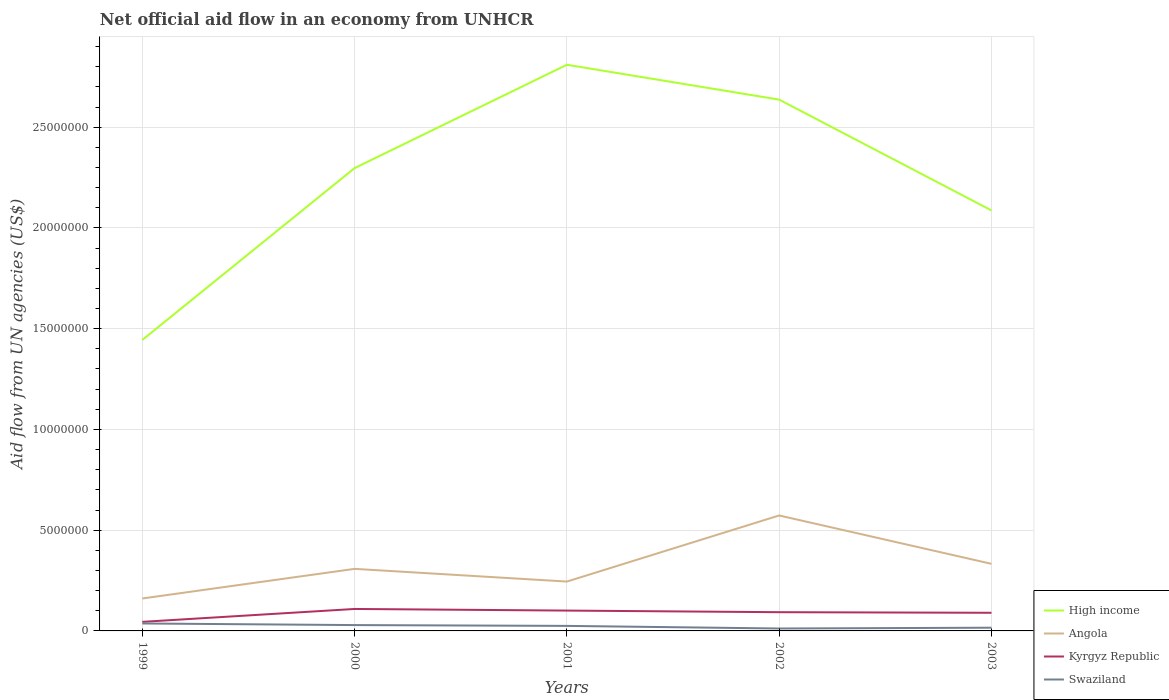How many different coloured lines are there?
Provide a short and direct response. 4. Across all years, what is the maximum net official aid flow in Swaziland?
Provide a succinct answer. 1.20e+05. What is the total net official aid flow in Swaziland in the graph?
Offer a very short reply. -4.00e+04. What is the difference between the highest and the second highest net official aid flow in Angola?
Ensure brevity in your answer.  4.12e+06. What is the difference between two consecutive major ticks on the Y-axis?
Keep it short and to the point. 5.00e+06. Where does the legend appear in the graph?
Your answer should be very brief. Bottom right. How are the legend labels stacked?
Your response must be concise. Vertical. What is the title of the graph?
Offer a terse response. Net official aid flow in an economy from UNHCR. What is the label or title of the Y-axis?
Offer a very short reply. Aid flow from UN agencies (US$). What is the Aid flow from UN agencies (US$) of High income in 1999?
Your answer should be compact. 1.44e+07. What is the Aid flow from UN agencies (US$) of Angola in 1999?
Ensure brevity in your answer.  1.61e+06. What is the Aid flow from UN agencies (US$) in Kyrgyz Republic in 1999?
Offer a very short reply. 4.50e+05. What is the Aid flow from UN agencies (US$) of Swaziland in 1999?
Keep it short and to the point. 3.70e+05. What is the Aid flow from UN agencies (US$) of High income in 2000?
Offer a terse response. 2.30e+07. What is the Aid flow from UN agencies (US$) of Angola in 2000?
Give a very brief answer. 3.08e+06. What is the Aid flow from UN agencies (US$) of Kyrgyz Republic in 2000?
Make the answer very short. 1.09e+06. What is the Aid flow from UN agencies (US$) in High income in 2001?
Offer a terse response. 2.81e+07. What is the Aid flow from UN agencies (US$) in Angola in 2001?
Keep it short and to the point. 2.45e+06. What is the Aid flow from UN agencies (US$) in Kyrgyz Republic in 2001?
Provide a short and direct response. 1.01e+06. What is the Aid flow from UN agencies (US$) in Swaziland in 2001?
Offer a terse response. 2.50e+05. What is the Aid flow from UN agencies (US$) of High income in 2002?
Offer a terse response. 2.64e+07. What is the Aid flow from UN agencies (US$) in Angola in 2002?
Provide a succinct answer. 5.73e+06. What is the Aid flow from UN agencies (US$) of Kyrgyz Republic in 2002?
Ensure brevity in your answer.  9.30e+05. What is the Aid flow from UN agencies (US$) of Swaziland in 2002?
Your answer should be very brief. 1.20e+05. What is the Aid flow from UN agencies (US$) of High income in 2003?
Give a very brief answer. 2.09e+07. What is the Aid flow from UN agencies (US$) of Angola in 2003?
Provide a short and direct response. 3.33e+06. What is the Aid flow from UN agencies (US$) of Swaziland in 2003?
Make the answer very short. 1.60e+05. Across all years, what is the maximum Aid flow from UN agencies (US$) in High income?
Keep it short and to the point. 2.81e+07. Across all years, what is the maximum Aid flow from UN agencies (US$) in Angola?
Your response must be concise. 5.73e+06. Across all years, what is the maximum Aid flow from UN agencies (US$) of Kyrgyz Republic?
Offer a very short reply. 1.09e+06. Across all years, what is the maximum Aid flow from UN agencies (US$) in Swaziland?
Offer a terse response. 3.70e+05. Across all years, what is the minimum Aid flow from UN agencies (US$) of High income?
Keep it short and to the point. 1.44e+07. Across all years, what is the minimum Aid flow from UN agencies (US$) of Angola?
Provide a succinct answer. 1.61e+06. Across all years, what is the minimum Aid flow from UN agencies (US$) of Kyrgyz Republic?
Keep it short and to the point. 4.50e+05. What is the total Aid flow from UN agencies (US$) of High income in the graph?
Provide a short and direct response. 1.13e+08. What is the total Aid flow from UN agencies (US$) in Angola in the graph?
Keep it short and to the point. 1.62e+07. What is the total Aid flow from UN agencies (US$) in Kyrgyz Republic in the graph?
Offer a terse response. 4.38e+06. What is the total Aid flow from UN agencies (US$) in Swaziland in the graph?
Your answer should be very brief. 1.19e+06. What is the difference between the Aid flow from UN agencies (US$) of High income in 1999 and that in 2000?
Your response must be concise. -8.53e+06. What is the difference between the Aid flow from UN agencies (US$) of Angola in 1999 and that in 2000?
Offer a terse response. -1.47e+06. What is the difference between the Aid flow from UN agencies (US$) in Kyrgyz Republic in 1999 and that in 2000?
Your answer should be very brief. -6.40e+05. What is the difference between the Aid flow from UN agencies (US$) of Swaziland in 1999 and that in 2000?
Provide a succinct answer. 8.00e+04. What is the difference between the Aid flow from UN agencies (US$) of High income in 1999 and that in 2001?
Your answer should be compact. -1.37e+07. What is the difference between the Aid flow from UN agencies (US$) of Angola in 1999 and that in 2001?
Keep it short and to the point. -8.40e+05. What is the difference between the Aid flow from UN agencies (US$) of Kyrgyz Republic in 1999 and that in 2001?
Keep it short and to the point. -5.60e+05. What is the difference between the Aid flow from UN agencies (US$) of Swaziland in 1999 and that in 2001?
Provide a succinct answer. 1.20e+05. What is the difference between the Aid flow from UN agencies (US$) in High income in 1999 and that in 2002?
Offer a very short reply. -1.19e+07. What is the difference between the Aid flow from UN agencies (US$) of Angola in 1999 and that in 2002?
Your response must be concise. -4.12e+06. What is the difference between the Aid flow from UN agencies (US$) of Kyrgyz Republic in 1999 and that in 2002?
Your answer should be very brief. -4.80e+05. What is the difference between the Aid flow from UN agencies (US$) in Swaziland in 1999 and that in 2002?
Your answer should be very brief. 2.50e+05. What is the difference between the Aid flow from UN agencies (US$) in High income in 1999 and that in 2003?
Provide a short and direct response. -6.43e+06. What is the difference between the Aid flow from UN agencies (US$) in Angola in 1999 and that in 2003?
Provide a short and direct response. -1.72e+06. What is the difference between the Aid flow from UN agencies (US$) in Kyrgyz Republic in 1999 and that in 2003?
Offer a very short reply. -4.50e+05. What is the difference between the Aid flow from UN agencies (US$) in High income in 2000 and that in 2001?
Ensure brevity in your answer.  -5.13e+06. What is the difference between the Aid flow from UN agencies (US$) in Angola in 2000 and that in 2001?
Provide a short and direct response. 6.30e+05. What is the difference between the Aid flow from UN agencies (US$) in Kyrgyz Republic in 2000 and that in 2001?
Offer a terse response. 8.00e+04. What is the difference between the Aid flow from UN agencies (US$) in Swaziland in 2000 and that in 2001?
Your answer should be very brief. 4.00e+04. What is the difference between the Aid flow from UN agencies (US$) in High income in 2000 and that in 2002?
Your answer should be very brief. -3.40e+06. What is the difference between the Aid flow from UN agencies (US$) in Angola in 2000 and that in 2002?
Your answer should be compact. -2.65e+06. What is the difference between the Aid flow from UN agencies (US$) of Kyrgyz Republic in 2000 and that in 2002?
Ensure brevity in your answer.  1.60e+05. What is the difference between the Aid flow from UN agencies (US$) of Swaziland in 2000 and that in 2002?
Your answer should be very brief. 1.70e+05. What is the difference between the Aid flow from UN agencies (US$) of High income in 2000 and that in 2003?
Keep it short and to the point. 2.10e+06. What is the difference between the Aid flow from UN agencies (US$) of Angola in 2000 and that in 2003?
Provide a succinct answer. -2.50e+05. What is the difference between the Aid flow from UN agencies (US$) of High income in 2001 and that in 2002?
Your response must be concise. 1.73e+06. What is the difference between the Aid flow from UN agencies (US$) of Angola in 2001 and that in 2002?
Offer a very short reply. -3.28e+06. What is the difference between the Aid flow from UN agencies (US$) of Kyrgyz Republic in 2001 and that in 2002?
Your answer should be compact. 8.00e+04. What is the difference between the Aid flow from UN agencies (US$) of Swaziland in 2001 and that in 2002?
Your answer should be compact. 1.30e+05. What is the difference between the Aid flow from UN agencies (US$) in High income in 2001 and that in 2003?
Your response must be concise. 7.23e+06. What is the difference between the Aid flow from UN agencies (US$) of Angola in 2001 and that in 2003?
Your answer should be very brief. -8.80e+05. What is the difference between the Aid flow from UN agencies (US$) in Kyrgyz Republic in 2001 and that in 2003?
Provide a succinct answer. 1.10e+05. What is the difference between the Aid flow from UN agencies (US$) of High income in 2002 and that in 2003?
Offer a terse response. 5.50e+06. What is the difference between the Aid flow from UN agencies (US$) of Angola in 2002 and that in 2003?
Offer a terse response. 2.40e+06. What is the difference between the Aid flow from UN agencies (US$) of High income in 1999 and the Aid flow from UN agencies (US$) of Angola in 2000?
Your answer should be compact. 1.14e+07. What is the difference between the Aid flow from UN agencies (US$) of High income in 1999 and the Aid flow from UN agencies (US$) of Kyrgyz Republic in 2000?
Offer a very short reply. 1.34e+07. What is the difference between the Aid flow from UN agencies (US$) of High income in 1999 and the Aid flow from UN agencies (US$) of Swaziland in 2000?
Keep it short and to the point. 1.42e+07. What is the difference between the Aid flow from UN agencies (US$) of Angola in 1999 and the Aid flow from UN agencies (US$) of Kyrgyz Republic in 2000?
Make the answer very short. 5.20e+05. What is the difference between the Aid flow from UN agencies (US$) in Angola in 1999 and the Aid flow from UN agencies (US$) in Swaziland in 2000?
Offer a very short reply. 1.32e+06. What is the difference between the Aid flow from UN agencies (US$) of High income in 1999 and the Aid flow from UN agencies (US$) of Angola in 2001?
Provide a succinct answer. 1.20e+07. What is the difference between the Aid flow from UN agencies (US$) of High income in 1999 and the Aid flow from UN agencies (US$) of Kyrgyz Republic in 2001?
Give a very brief answer. 1.34e+07. What is the difference between the Aid flow from UN agencies (US$) of High income in 1999 and the Aid flow from UN agencies (US$) of Swaziland in 2001?
Give a very brief answer. 1.42e+07. What is the difference between the Aid flow from UN agencies (US$) of Angola in 1999 and the Aid flow from UN agencies (US$) of Kyrgyz Republic in 2001?
Ensure brevity in your answer.  6.00e+05. What is the difference between the Aid flow from UN agencies (US$) in Angola in 1999 and the Aid flow from UN agencies (US$) in Swaziland in 2001?
Give a very brief answer. 1.36e+06. What is the difference between the Aid flow from UN agencies (US$) in High income in 1999 and the Aid flow from UN agencies (US$) in Angola in 2002?
Ensure brevity in your answer.  8.71e+06. What is the difference between the Aid flow from UN agencies (US$) in High income in 1999 and the Aid flow from UN agencies (US$) in Kyrgyz Republic in 2002?
Give a very brief answer. 1.35e+07. What is the difference between the Aid flow from UN agencies (US$) of High income in 1999 and the Aid flow from UN agencies (US$) of Swaziland in 2002?
Make the answer very short. 1.43e+07. What is the difference between the Aid flow from UN agencies (US$) in Angola in 1999 and the Aid flow from UN agencies (US$) in Kyrgyz Republic in 2002?
Give a very brief answer. 6.80e+05. What is the difference between the Aid flow from UN agencies (US$) in Angola in 1999 and the Aid flow from UN agencies (US$) in Swaziland in 2002?
Provide a short and direct response. 1.49e+06. What is the difference between the Aid flow from UN agencies (US$) in High income in 1999 and the Aid flow from UN agencies (US$) in Angola in 2003?
Provide a short and direct response. 1.11e+07. What is the difference between the Aid flow from UN agencies (US$) of High income in 1999 and the Aid flow from UN agencies (US$) of Kyrgyz Republic in 2003?
Your answer should be very brief. 1.35e+07. What is the difference between the Aid flow from UN agencies (US$) of High income in 1999 and the Aid flow from UN agencies (US$) of Swaziland in 2003?
Offer a very short reply. 1.43e+07. What is the difference between the Aid flow from UN agencies (US$) of Angola in 1999 and the Aid flow from UN agencies (US$) of Kyrgyz Republic in 2003?
Your answer should be very brief. 7.10e+05. What is the difference between the Aid flow from UN agencies (US$) of Angola in 1999 and the Aid flow from UN agencies (US$) of Swaziland in 2003?
Your answer should be very brief. 1.45e+06. What is the difference between the Aid flow from UN agencies (US$) of Kyrgyz Republic in 1999 and the Aid flow from UN agencies (US$) of Swaziland in 2003?
Provide a succinct answer. 2.90e+05. What is the difference between the Aid flow from UN agencies (US$) in High income in 2000 and the Aid flow from UN agencies (US$) in Angola in 2001?
Make the answer very short. 2.05e+07. What is the difference between the Aid flow from UN agencies (US$) in High income in 2000 and the Aid flow from UN agencies (US$) in Kyrgyz Republic in 2001?
Your response must be concise. 2.20e+07. What is the difference between the Aid flow from UN agencies (US$) in High income in 2000 and the Aid flow from UN agencies (US$) in Swaziland in 2001?
Ensure brevity in your answer.  2.27e+07. What is the difference between the Aid flow from UN agencies (US$) in Angola in 2000 and the Aid flow from UN agencies (US$) in Kyrgyz Republic in 2001?
Provide a succinct answer. 2.07e+06. What is the difference between the Aid flow from UN agencies (US$) in Angola in 2000 and the Aid flow from UN agencies (US$) in Swaziland in 2001?
Your response must be concise. 2.83e+06. What is the difference between the Aid flow from UN agencies (US$) in Kyrgyz Republic in 2000 and the Aid flow from UN agencies (US$) in Swaziland in 2001?
Your answer should be compact. 8.40e+05. What is the difference between the Aid flow from UN agencies (US$) in High income in 2000 and the Aid flow from UN agencies (US$) in Angola in 2002?
Provide a succinct answer. 1.72e+07. What is the difference between the Aid flow from UN agencies (US$) of High income in 2000 and the Aid flow from UN agencies (US$) of Kyrgyz Republic in 2002?
Ensure brevity in your answer.  2.20e+07. What is the difference between the Aid flow from UN agencies (US$) in High income in 2000 and the Aid flow from UN agencies (US$) in Swaziland in 2002?
Provide a short and direct response. 2.28e+07. What is the difference between the Aid flow from UN agencies (US$) of Angola in 2000 and the Aid flow from UN agencies (US$) of Kyrgyz Republic in 2002?
Ensure brevity in your answer.  2.15e+06. What is the difference between the Aid flow from UN agencies (US$) in Angola in 2000 and the Aid flow from UN agencies (US$) in Swaziland in 2002?
Offer a very short reply. 2.96e+06. What is the difference between the Aid flow from UN agencies (US$) of Kyrgyz Republic in 2000 and the Aid flow from UN agencies (US$) of Swaziland in 2002?
Make the answer very short. 9.70e+05. What is the difference between the Aid flow from UN agencies (US$) of High income in 2000 and the Aid flow from UN agencies (US$) of Angola in 2003?
Your answer should be compact. 1.96e+07. What is the difference between the Aid flow from UN agencies (US$) in High income in 2000 and the Aid flow from UN agencies (US$) in Kyrgyz Republic in 2003?
Provide a succinct answer. 2.21e+07. What is the difference between the Aid flow from UN agencies (US$) of High income in 2000 and the Aid flow from UN agencies (US$) of Swaziland in 2003?
Offer a terse response. 2.28e+07. What is the difference between the Aid flow from UN agencies (US$) of Angola in 2000 and the Aid flow from UN agencies (US$) of Kyrgyz Republic in 2003?
Make the answer very short. 2.18e+06. What is the difference between the Aid flow from UN agencies (US$) in Angola in 2000 and the Aid flow from UN agencies (US$) in Swaziland in 2003?
Provide a short and direct response. 2.92e+06. What is the difference between the Aid flow from UN agencies (US$) of Kyrgyz Republic in 2000 and the Aid flow from UN agencies (US$) of Swaziland in 2003?
Provide a short and direct response. 9.30e+05. What is the difference between the Aid flow from UN agencies (US$) in High income in 2001 and the Aid flow from UN agencies (US$) in Angola in 2002?
Your answer should be compact. 2.24e+07. What is the difference between the Aid flow from UN agencies (US$) of High income in 2001 and the Aid flow from UN agencies (US$) of Kyrgyz Republic in 2002?
Make the answer very short. 2.72e+07. What is the difference between the Aid flow from UN agencies (US$) in High income in 2001 and the Aid flow from UN agencies (US$) in Swaziland in 2002?
Give a very brief answer. 2.80e+07. What is the difference between the Aid flow from UN agencies (US$) in Angola in 2001 and the Aid flow from UN agencies (US$) in Kyrgyz Republic in 2002?
Provide a succinct answer. 1.52e+06. What is the difference between the Aid flow from UN agencies (US$) of Angola in 2001 and the Aid flow from UN agencies (US$) of Swaziland in 2002?
Your response must be concise. 2.33e+06. What is the difference between the Aid flow from UN agencies (US$) of Kyrgyz Republic in 2001 and the Aid flow from UN agencies (US$) of Swaziland in 2002?
Ensure brevity in your answer.  8.90e+05. What is the difference between the Aid flow from UN agencies (US$) of High income in 2001 and the Aid flow from UN agencies (US$) of Angola in 2003?
Your answer should be very brief. 2.48e+07. What is the difference between the Aid flow from UN agencies (US$) of High income in 2001 and the Aid flow from UN agencies (US$) of Kyrgyz Republic in 2003?
Keep it short and to the point. 2.72e+07. What is the difference between the Aid flow from UN agencies (US$) in High income in 2001 and the Aid flow from UN agencies (US$) in Swaziland in 2003?
Offer a terse response. 2.79e+07. What is the difference between the Aid flow from UN agencies (US$) in Angola in 2001 and the Aid flow from UN agencies (US$) in Kyrgyz Republic in 2003?
Ensure brevity in your answer.  1.55e+06. What is the difference between the Aid flow from UN agencies (US$) in Angola in 2001 and the Aid flow from UN agencies (US$) in Swaziland in 2003?
Provide a succinct answer. 2.29e+06. What is the difference between the Aid flow from UN agencies (US$) of Kyrgyz Republic in 2001 and the Aid flow from UN agencies (US$) of Swaziland in 2003?
Give a very brief answer. 8.50e+05. What is the difference between the Aid flow from UN agencies (US$) in High income in 2002 and the Aid flow from UN agencies (US$) in Angola in 2003?
Your answer should be compact. 2.30e+07. What is the difference between the Aid flow from UN agencies (US$) in High income in 2002 and the Aid flow from UN agencies (US$) in Kyrgyz Republic in 2003?
Your answer should be very brief. 2.55e+07. What is the difference between the Aid flow from UN agencies (US$) of High income in 2002 and the Aid flow from UN agencies (US$) of Swaziland in 2003?
Your answer should be compact. 2.62e+07. What is the difference between the Aid flow from UN agencies (US$) in Angola in 2002 and the Aid flow from UN agencies (US$) in Kyrgyz Republic in 2003?
Offer a terse response. 4.83e+06. What is the difference between the Aid flow from UN agencies (US$) of Angola in 2002 and the Aid flow from UN agencies (US$) of Swaziland in 2003?
Give a very brief answer. 5.57e+06. What is the difference between the Aid flow from UN agencies (US$) of Kyrgyz Republic in 2002 and the Aid flow from UN agencies (US$) of Swaziland in 2003?
Your response must be concise. 7.70e+05. What is the average Aid flow from UN agencies (US$) in High income per year?
Your response must be concise. 2.26e+07. What is the average Aid flow from UN agencies (US$) of Angola per year?
Your response must be concise. 3.24e+06. What is the average Aid flow from UN agencies (US$) of Kyrgyz Republic per year?
Offer a very short reply. 8.76e+05. What is the average Aid flow from UN agencies (US$) of Swaziland per year?
Ensure brevity in your answer.  2.38e+05. In the year 1999, what is the difference between the Aid flow from UN agencies (US$) of High income and Aid flow from UN agencies (US$) of Angola?
Give a very brief answer. 1.28e+07. In the year 1999, what is the difference between the Aid flow from UN agencies (US$) of High income and Aid flow from UN agencies (US$) of Kyrgyz Republic?
Your answer should be compact. 1.40e+07. In the year 1999, what is the difference between the Aid flow from UN agencies (US$) in High income and Aid flow from UN agencies (US$) in Swaziland?
Your response must be concise. 1.41e+07. In the year 1999, what is the difference between the Aid flow from UN agencies (US$) of Angola and Aid flow from UN agencies (US$) of Kyrgyz Republic?
Ensure brevity in your answer.  1.16e+06. In the year 1999, what is the difference between the Aid flow from UN agencies (US$) of Angola and Aid flow from UN agencies (US$) of Swaziland?
Give a very brief answer. 1.24e+06. In the year 1999, what is the difference between the Aid flow from UN agencies (US$) in Kyrgyz Republic and Aid flow from UN agencies (US$) in Swaziland?
Offer a very short reply. 8.00e+04. In the year 2000, what is the difference between the Aid flow from UN agencies (US$) of High income and Aid flow from UN agencies (US$) of Angola?
Ensure brevity in your answer.  1.99e+07. In the year 2000, what is the difference between the Aid flow from UN agencies (US$) of High income and Aid flow from UN agencies (US$) of Kyrgyz Republic?
Your answer should be very brief. 2.19e+07. In the year 2000, what is the difference between the Aid flow from UN agencies (US$) in High income and Aid flow from UN agencies (US$) in Swaziland?
Provide a short and direct response. 2.27e+07. In the year 2000, what is the difference between the Aid flow from UN agencies (US$) of Angola and Aid flow from UN agencies (US$) of Kyrgyz Republic?
Give a very brief answer. 1.99e+06. In the year 2000, what is the difference between the Aid flow from UN agencies (US$) in Angola and Aid flow from UN agencies (US$) in Swaziland?
Your response must be concise. 2.79e+06. In the year 2000, what is the difference between the Aid flow from UN agencies (US$) in Kyrgyz Republic and Aid flow from UN agencies (US$) in Swaziland?
Offer a very short reply. 8.00e+05. In the year 2001, what is the difference between the Aid flow from UN agencies (US$) of High income and Aid flow from UN agencies (US$) of Angola?
Make the answer very short. 2.56e+07. In the year 2001, what is the difference between the Aid flow from UN agencies (US$) in High income and Aid flow from UN agencies (US$) in Kyrgyz Republic?
Keep it short and to the point. 2.71e+07. In the year 2001, what is the difference between the Aid flow from UN agencies (US$) of High income and Aid flow from UN agencies (US$) of Swaziland?
Keep it short and to the point. 2.78e+07. In the year 2001, what is the difference between the Aid flow from UN agencies (US$) in Angola and Aid flow from UN agencies (US$) in Kyrgyz Republic?
Make the answer very short. 1.44e+06. In the year 2001, what is the difference between the Aid flow from UN agencies (US$) of Angola and Aid flow from UN agencies (US$) of Swaziland?
Your answer should be compact. 2.20e+06. In the year 2001, what is the difference between the Aid flow from UN agencies (US$) in Kyrgyz Republic and Aid flow from UN agencies (US$) in Swaziland?
Your response must be concise. 7.60e+05. In the year 2002, what is the difference between the Aid flow from UN agencies (US$) in High income and Aid flow from UN agencies (US$) in Angola?
Offer a terse response. 2.06e+07. In the year 2002, what is the difference between the Aid flow from UN agencies (US$) in High income and Aid flow from UN agencies (US$) in Kyrgyz Republic?
Offer a very short reply. 2.54e+07. In the year 2002, what is the difference between the Aid flow from UN agencies (US$) in High income and Aid flow from UN agencies (US$) in Swaziland?
Make the answer very short. 2.62e+07. In the year 2002, what is the difference between the Aid flow from UN agencies (US$) in Angola and Aid flow from UN agencies (US$) in Kyrgyz Republic?
Provide a succinct answer. 4.80e+06. In the year 2002, what is the difference between the Aid flow from UN agencies (US$) in Angola and Aid flow from UN agencies (US$) in Swaziland?
Your answer should be compact. 5.61e+06. In the year 2002, what is the difference between the Aid flow from UN agencies (US$) in Kyrgyz Republic and Aid flow from UN agencies (US$) in Swaziland?
Your response must be concise. 8.10e+05. In the year 2003, what is the difference between the Aid flow from UN agencies (US$) of High income and Aid flow from UN agencies (US$) of Angola?
Provide a short and direct response. 1.75e+07. In the year 2003, what is the difference between the Aid flow from UN agencies (US$) in High income and Aid flow from UN agencies (US$) in Kyrgyz Republic?
Offer a terse response. 2.00e+07. In the year 2003, what is the difference between the Aid flow from UN agencies (US$) of High income and Aid flow from UN agencies (US$) of Swaziland?
Ensure brevity in your answer.  2.07e+07. In the year 2003, what is the difference between the Aid flow from UN agencies (US$) of Angola and Aid flow from UN agencies (US$) of Kyrgyz Republic?
Your answer should be compact. 2.43e+06. In the year 2003, what is the difference between the Aid flow from UN agencies (US$) of Angola and Aid flow from UN agencies (US$) of Swaziland?
Keep it short and to the point. 3.17e+06. In the year 2003, what is the difference between the Aid flow from UN agencies (US$) in Kyrgyz Republic and Aid flow from UN agencies (US$) in Swaziland?
Make the answer very short. 7.40e+05. What is the ratio of the Aid flow from UN agencies (US$) of High income in 1999 to that in 2000?
Offer a terse response. 0.63. What is the ratio of the Aid flow from UN agencies (US$) in Angola in 1999 to that in 2000?
Provide a short and direct response. 0.52. What is the ratio of the Aid flow from UN agencies (US$) of Kyrgyz Republic in 1999 to that in 2000?
Your response must be concise. 0.41. What is the ratio of the Aid flow from UN agencies (US$) of Swaziland in 1999 to that in 2000?
Give a very brief answer. 1.28. What is the ratio of the Aid flow from UN agencies (US$) in High income in 1999 to that in 2001?
Give a very brief answer. 0.51. What is the ratio of the Aid flow from UN agencies (US$) of Angola in 1999 to that in 2001?
Make the answer very short. 0.66. What is the ratio of the Aid flow from UN agencies (US$) of Kyrgyz Republic in 1999 to that in 2001?
Give a very brief answer. 0.45. What is the ratio of the Aid flow from UN agencies (US$) in Swaziland in 1999 to that in 2001?
Your response must be concise. 1.48. What is the ratio of the Aid flow from UN agencies (US$) of High income in 1999 to that in 2002?
Offer a terse response. 0.55. What is the ratio of the Aid flow from UN agencies (US$) of Angola in 1999 to that in 2002?
Offer a terse response. 0.28. What is the ratio of the Aid flow from UN agencies (US$) in Kyrgyz Republic in 1999 to that in 2002?
Your answer should be compact. 0.48. What is the ratio of the Aid flow from UN agencies (US$) in Swaziland in 1999 to that in 2002?
Provide a short and direct response. 3.08. What is the ratio of the Aid flow from UN agencies (US$) of High income in 1999 to that in 2003?
Make the answer very short. 0.69. What is the ratio of the Aid flow from UN agencies (US$) in Angola in 1999 to that in 2003?
Make the answer very short. 0.48. What is the ratio of the Aid flow from UN agencies (US$) of Swaziland in 1999 to that in 2003?
Give a very brief answer. 2.31. What is the ratio of the Aid flow from UN agencies (US$) in High income in 2000 to that in 2001?
Give a very brief answer. 0.82. What is the ratio of the Aid flow from UN agencies (US$) of Angola in 2000 to that in 2001?
Offer a very short reply. 1.26. What is the ratio of the Aid flow from UN agencies (US$) in Kyrgyz Republic in 2000 to that in 2001?
Keep it short and to the point. 1.08. What is the ratio of the Aid flow from UN agencies (US$) in Swaziland in 2000 to that in 2001?
Provide a short and direct response. 1.16. What is the ratio of the Aid flow from UN agencies (US$) in High income in 2000 to that in 2002?
Keep it short and to the point. 0.87. What is the ratio of the Aid flow from UN agencies (US$) of Angola in 2000 to that in 2002?
Offer a terse response. 0.54. What is the ratio of the Aid flow from UN agencies (US$) in Kyrgyz Republic in 2000 to that in 2002?
Your response must be concise. 1.17. What is the ratio of the Aid flow from UN agencies (US$) of Swaziland in 2000 to that in 2002?
Provide a succinct answer. 2.42. What is the ratio of the Aid flow from UN agencies (US$) of High income in 2000 to that in 2003?
Provide a short and direct response. 1.1. What is the ratio of the Aid flow from UN agencies (US$) of Angola in 2000 to that in 2003?
Make the answer very short. 0.92. What is the ratio of the Aid flow from UN agencies (US$) in Kyrgyz Republic in 2000 to that in 2003?
Offer a terse response. 1.21. What is the ratio of the Aid flow from UN agencies (US$) in Swaziland in 2000 to that in 2003?
Offer a terse response. 1.81. What is the ratio of the Aid flow from UN agencies (US$) of High income in 2001 to that in 2002?
Your answer should be very brief. 1.07. What is the ratio of the Aid flow from UN agencies (US$) of Angola in 2001 to that in 2002?
Your answer should be compact. 0.43. What is the ratio of the Aid flow from UN agencies (US$) in Kyrgyz Republic in 2001 to that in 2002?
Offer a terse response. 1.09. What is the ratio of the Aid flow from UN agencies (US$) in Swaziland in 2001 to that in 2002?
Your response must be concise. 2.08. What is the ratio of the Aid flow from UN agencies (US$) of High income in 2001 to that in 2003?
Ensure brevity in your answer.  1.35. What is the ratio of the Aid flow from UN agencies (US$) of Angola in 2001 to that in 2003?
Your answer should be very brief. 0.74. What is the ratio of the Aid flow from UN agencies (US$) in Kyrgyz Republic in 2001 to that in 2003?
Your answer should be very brief. 1.12. What is the ratio of the Aid flow from UN agencies (US$) of Swaziland in 2001 to that in 2003?
Provide a succinct answer. 1.56. What is the ratio of the Aid flow from UN agencies (US$) of High income in 2002 to that in 2003?
Offer a terse response. 1.26. What is the ratio of the Aid flow from UN agencies (US$) of Angola in 2002 to that in 2003?
Your answer should be compact. 1.72. What is the ratio of the Aid flow from UN agencies (US$) in Kyrgyz Republic in 2002 to that in 2003?
Make the answer very short. 1.03. What is the difference between the highest and the second highest Aid flow from UN agencies (US$) in High income?
Your answer should be very brief. 1.73e+06. What is the difference between the highest and the second highest Aid flow from UN agencies (US$) of Angola?
Your answer should be very brief. 2.40e+06. What is the difference between the highest and the second highest Aid flow from UN agencies (US$) in Kyrgyz Republic?
Ensure brevity in your answer.  8.00e+04. What is the difference between the highest and the lowest Aid flow from UN agencies (US$) of High income?
Your answer should be very brief. 1.37e+07. What is the difference between the highest and the lowest Aid flow from UN agencies (US$) in Angola?
Provide a succinct answer. 4.12e+06. What is the difference between the highest and the lowest Aid flow from UN agencies (US$) of Kyrgyz Republic?
Give a very brief answer. 6.40e+05. What is the difference between the highest and the lowest Aid flow from UN agencies (US$) in Swaziland?
Your answer should be very brief. 2.50e+05. 